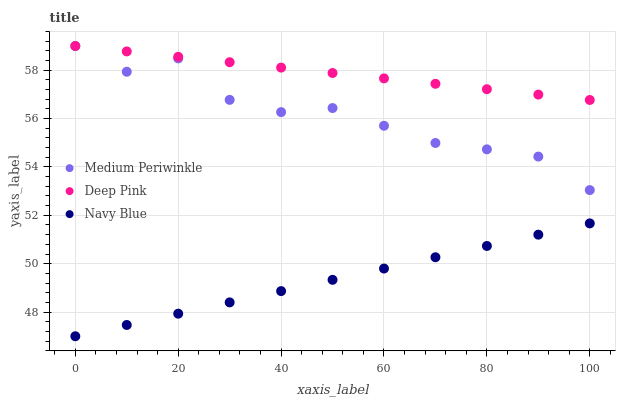Does Navy Blue have the minimum area under the curve?
Answer yes or no. Yes. Does Deep Pink have the maximum area under the curve?
Answer yes or no. Yes. Does Medium Periwinkle have the minimum area under the curve?
Answer yes or no. No. Does Medium Periwinkle have the maximum area under the curve?
Answer yes or no. No. Is Deep Pink the smoothest?
Answer yes or no. Yes. Is Medium Periwinkle the roughest?
Answer yes or no. Yes. Is Medium Periwinkle the smoothest?
Answer yes or no. No. Is Deep Pink the roughest?
Answer yes or no. No. Does Navy Blue have the lowest value?
Answer yes or no. Yes. Does Medium Periwinkle have the lowest value?
Answer yes or no. No. Does Medium Periwinkle have the highest value?
Answer yes or no. Yes. Is Navy Blue less than Medium Periwinkle?
Answer yes or no. Yes. Is Deep Pink greater than Navy Blue?
Answer yes or no. Yes. Does Medium Periwinkle intersect Deep Pink?
Answer yes or no. Yes. Is Medium Periwinkle less than Deep Pink?
Answer yes or no. No. Is Medium Periwinkle greater than Deep Pink?
Answer yes or no. No. Does Navy Blue intersect Medium Periwinkle?
Answer yes or no. No. 